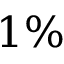Convert formula to latex. <formula><loc_0><loc_0><loc_500><loc_500>1 \%</formula> 